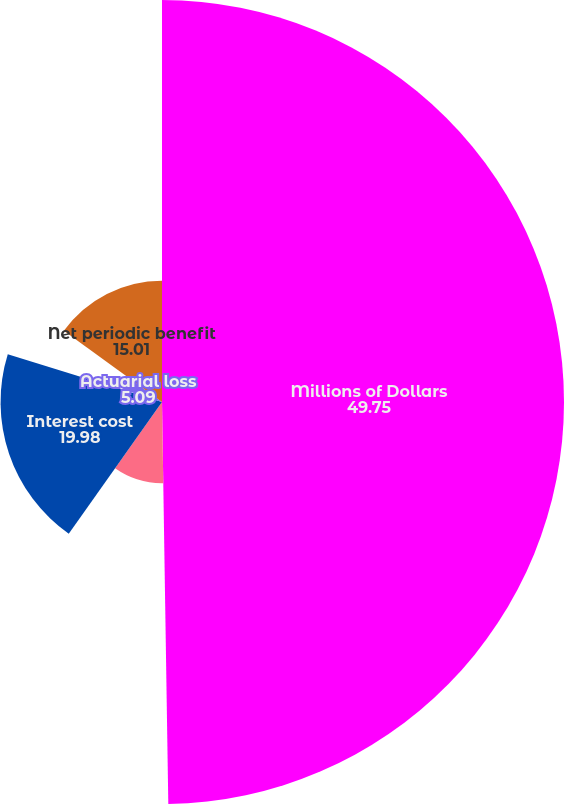Convert chart. <chart><loc_0><loc_0><loc_500><loc_500><pie_chart><fcel>Millions of Dollars<fcel>Service cost<fcel>Interest cost<fcel>Prior service cost/(credit)<fcel>Actuarial loss<fcel>Net periodic benefit<nl><fcel>49.75%<fcel>10.05%<fcel>19.98%<fcel>0.12%<fcel>5.09%<fcel>15.01%<nl></chart> 